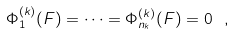Convert formula to latex. <formula><loc_0><loc_0><loc_500><loc_500>\Phi ^ { ( k ) } _ { 1 } ( F ) = \dots = \Phi ^ { ( k ) } _ { n _ { k } } ( F ) = 0 \ ,</formula> 